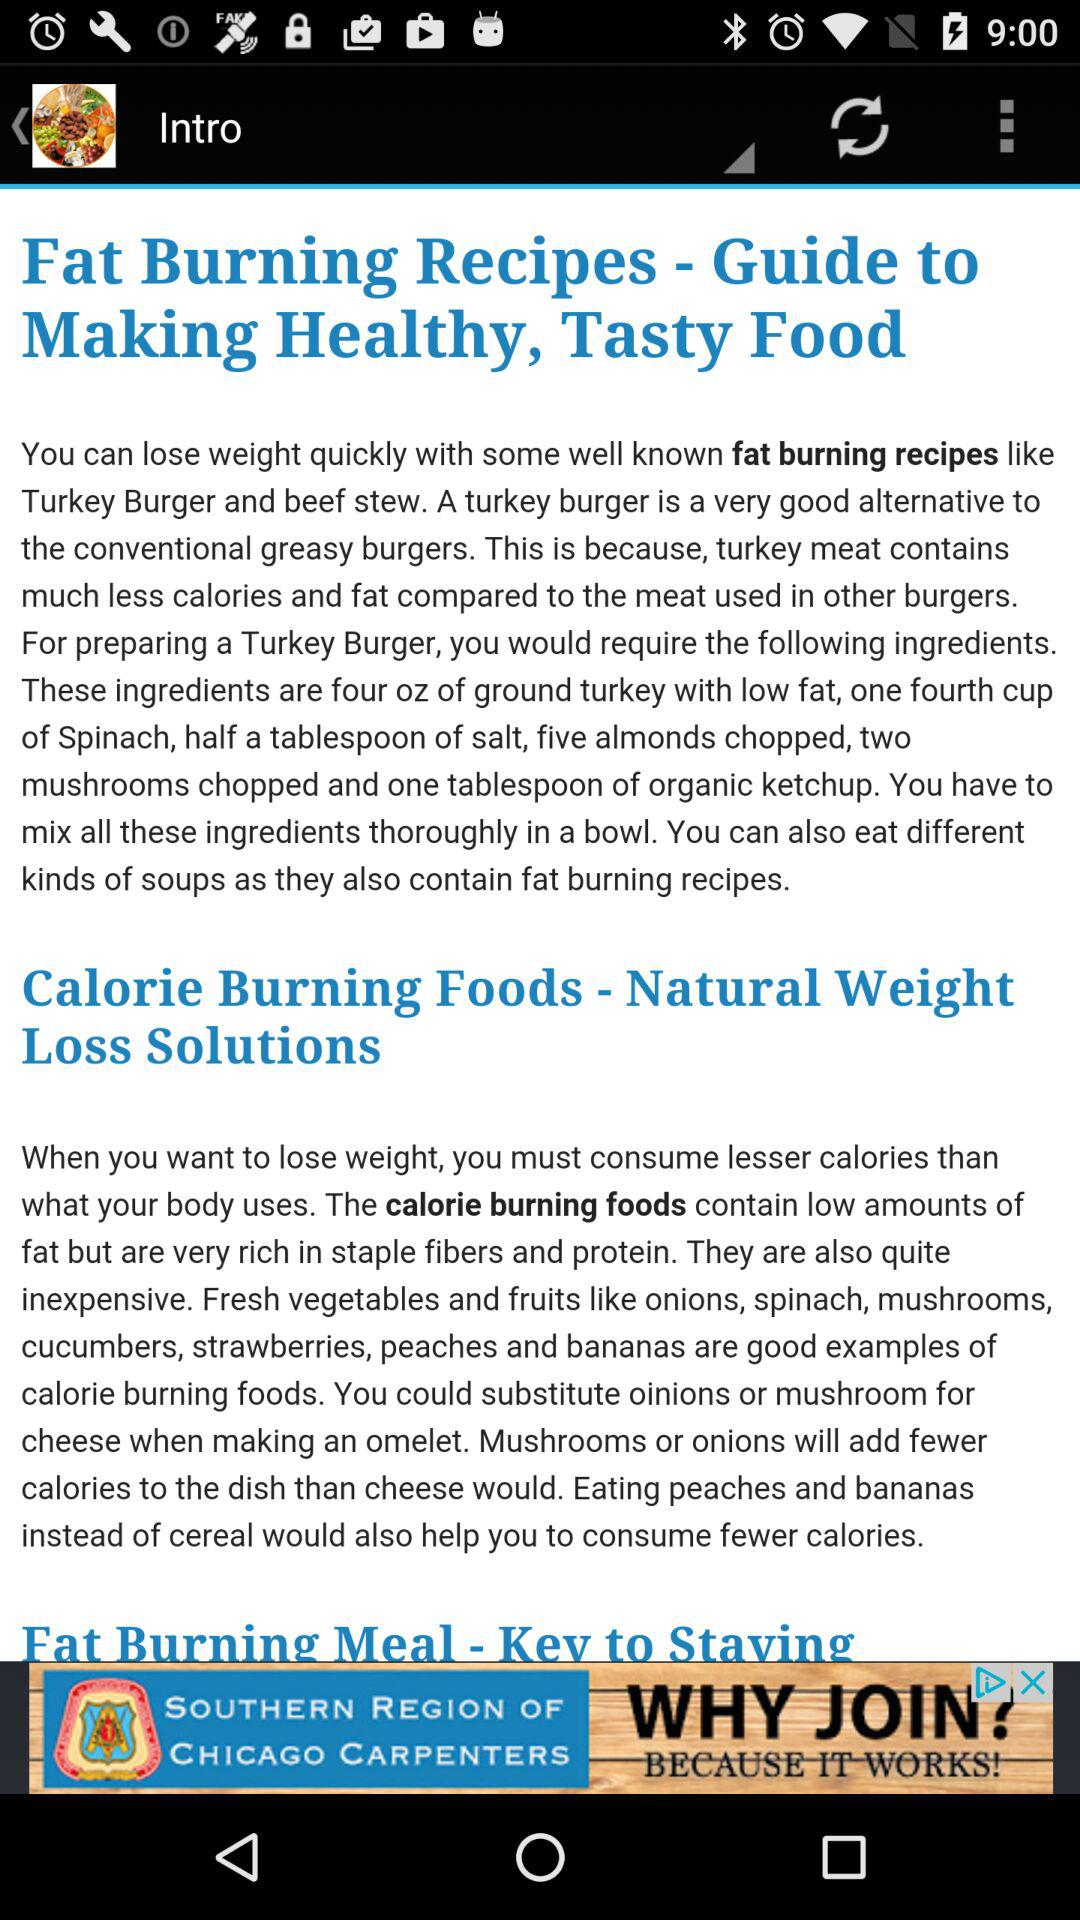Which fruits can be used to burn calories? The fruits that can be used to burn calories are strawberries, peaches and bananas. 